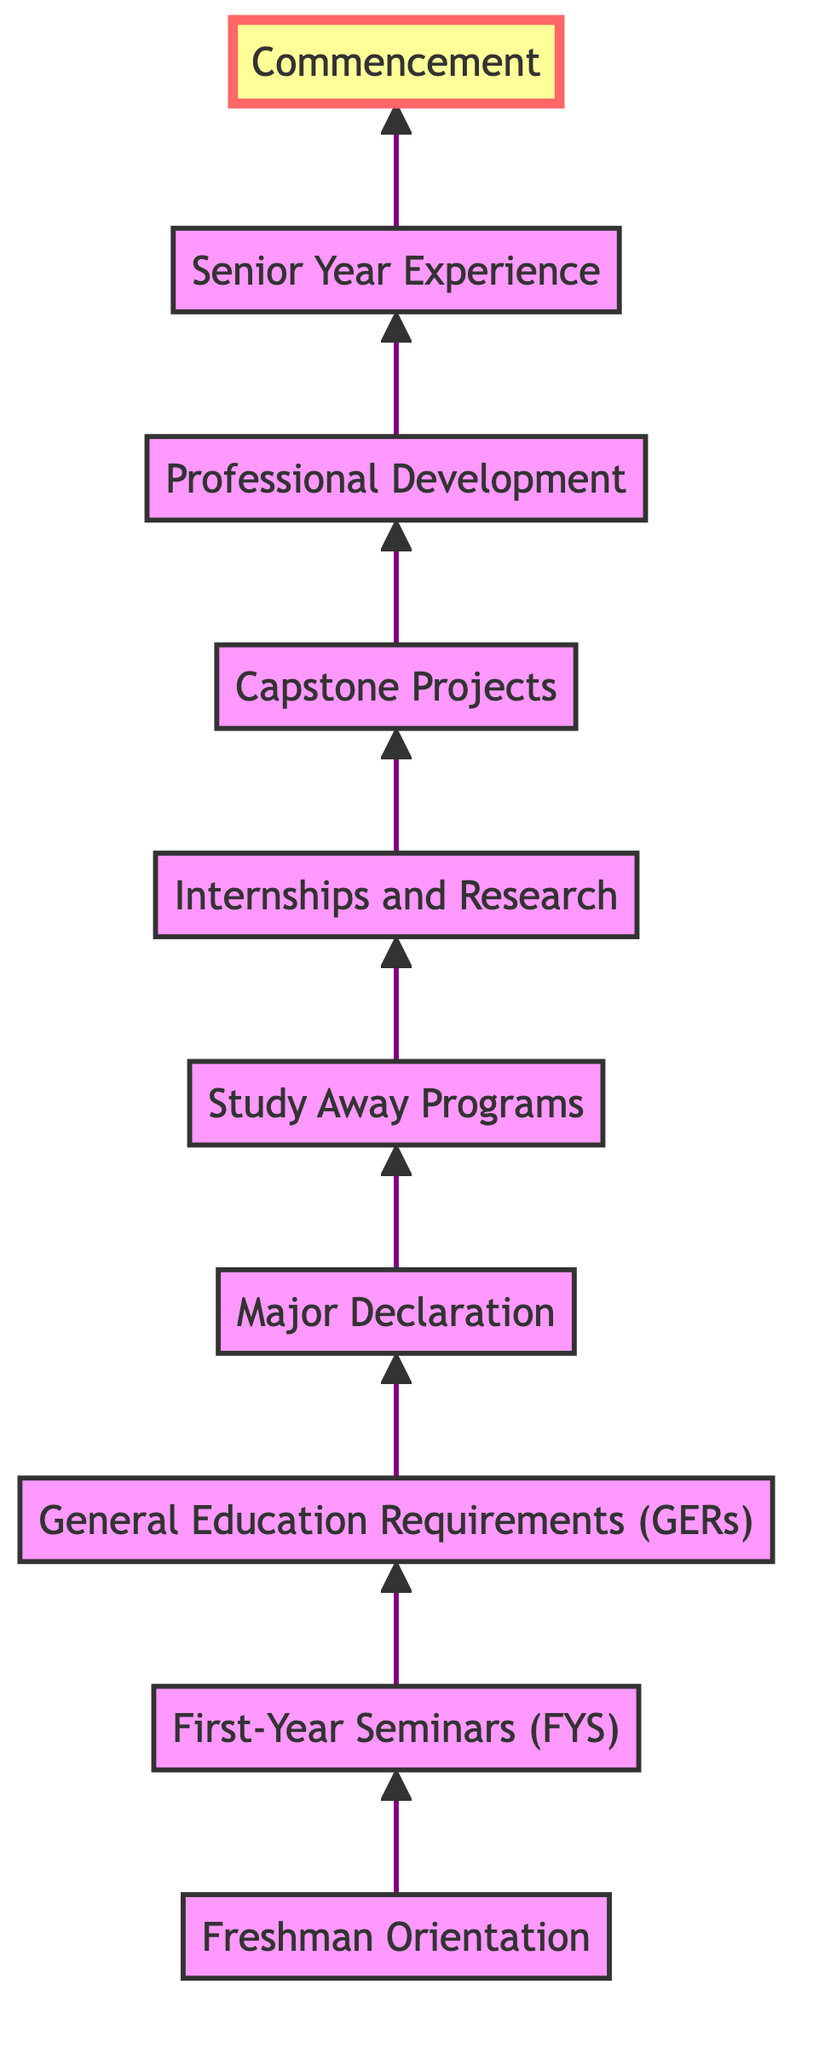What is the first stage in the academic journey? The diagram starts with the "Freshman Orientation" stage at the bottom.
Answer: Freshman Orientation How many stages are there in the diagram? By counting each stage listed from "Freshman Orientation" to "Commencement," there are ten stages in total.
Answer: 10 What follows First-Year Seminars (FYS)? The arrow indicates that after "First-Year Seminars (FYS)," the next stage is "General Education Requirements (GERs)."
Answer: General Education Requirements (GERs) Which stage appears directly before Commencement? "Senior Year Experience" is the stage directly before "Commencement" in the upward flow.
Answer: Senior Year Experience What is the main purpose of Major Declaration? The node describes that its main purpose is to choose a field of study by the end of the sophomore year with guidance from academic advisors.
Answer: Choosing a field of study What do students gain from internships and research? The description highlights that students gain hands-on experience through internships and undergraduate research.
Answer: Hands-on experience Between which stages do Study Away Programs fit? The arrow shows "Study Away Programs" fits between "Major Declaration" and "Internships and Research."
Answer: Between Major Declaration and Internships and Research How is Professional Development represented in the diagram? The "Professional Development" stage is shown as a step that includes career counseling services and networking events, aimed at aiding students' career readiness.
Answer: Career counseling services What characterizes the Capstone Projects stage? The description states that Capstone Projects are comprehensive projects or theses required in many majors, showcasing students' knowledge and skills.
Answer: Comprehensive projects or theses Which stage represents the completion of the academic journey? The "Commencement" stage at the top of the diagram signifies the final celebration of academic achievement.
Answer: Commencement 